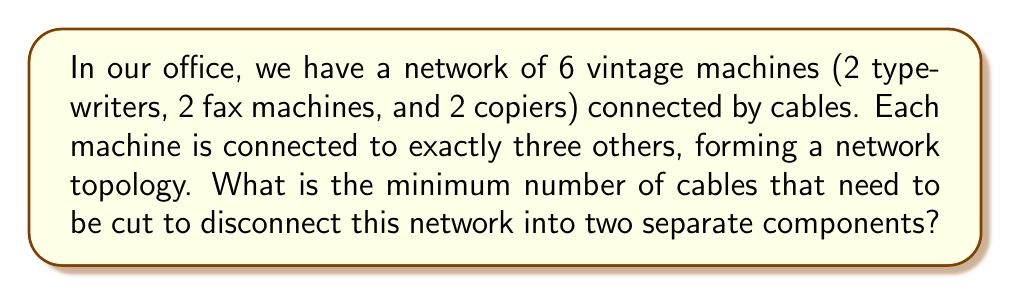Show me your answer to this math problem. To solve this problem, we need to understand the concept of connectivity in graph theory, which is directly applicable to network topology.

1) First, let's model our office machine network as a graph:
   - Each machine is a vertex
   - Each cable connection is an edge
   - We have 6 vertices, each with degree 3 (connected to 3 others)

2) This description matches the properties of a 3-regular graph with 6 vertices.

3) In graph theory, the minimum number of edges that need to be removed to disconnect a graph is called the edge connectivity of the graph.

4) For a k-regular graph (where k is the degree of each vertex), a theorem states that the edge connectivity is always less than or equal to k.

5) In our case, k = 3, so the edge connectivity is at most 3.

6) However, we can prove that it's exactly 3:
   - If we remove any 2 edges, the graph will still be connected.
   - There exists a set of 3 edges whose removal will disconnect the graph.

7) To visualize this, we can imagine the 6 machines arranged in a circle:
   [asy]
   unitsize(2cm);
   for(int i=0; i<6; ++i) {
     dot((cos(2pi*i/6), sin(2pi*i/6)));
     draw((cos(2pi*i/6), sin(2pi*i/6))--(cos(2pi*((i+1)%6)/6), sin(2pi*((i+1)%6)/6)));
     draw((cos(2pi*i/6), sin(2pi*i/6))--(cos(2pi*((i+3)%6)/6), sin(2pi*((i+3)%6)/6)));
   }
   [/asy]

8) Removing any 3 alternate edges in this circular arrangement will disconnect the graph into two components of 3 vertices each.

Therefore, the minimum number of cables that need to be cut to disconnect the network is 3.
Answer: 3 cables 